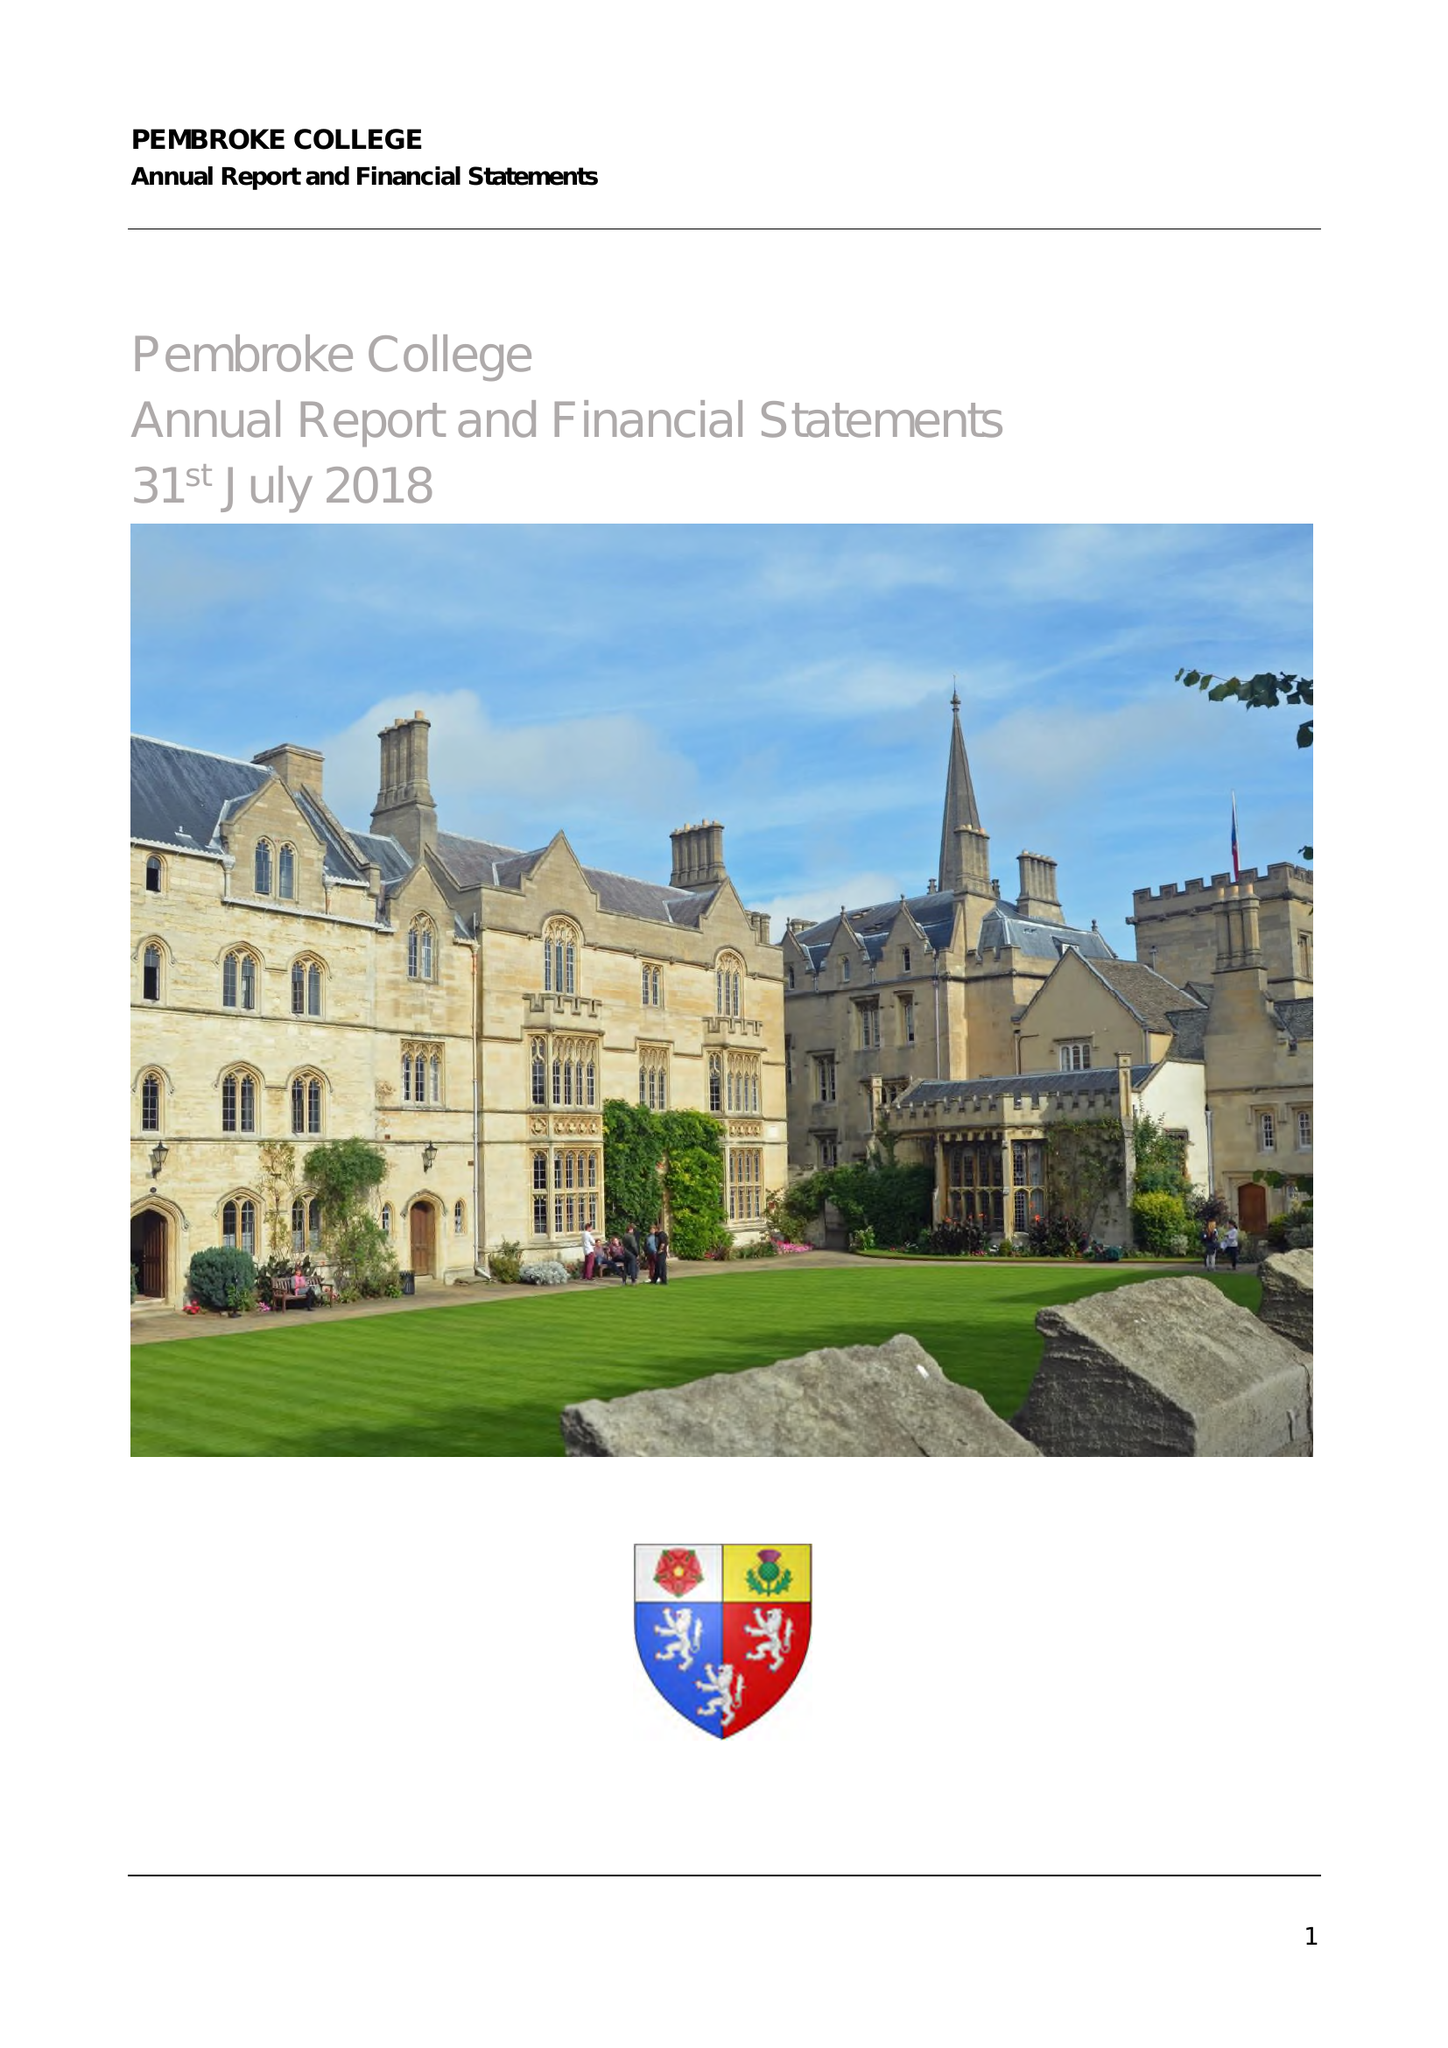What is the value for the charity_name?
Answer the question using a single word or phrase. Master Fellows and Scholars Of Pembroke College 